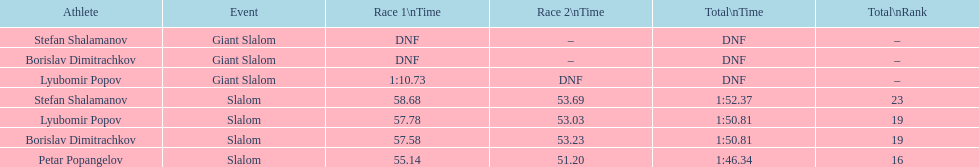Which sportsperson completed the initial race but failed to finish the subsequent one? Lyubomir Popov. 